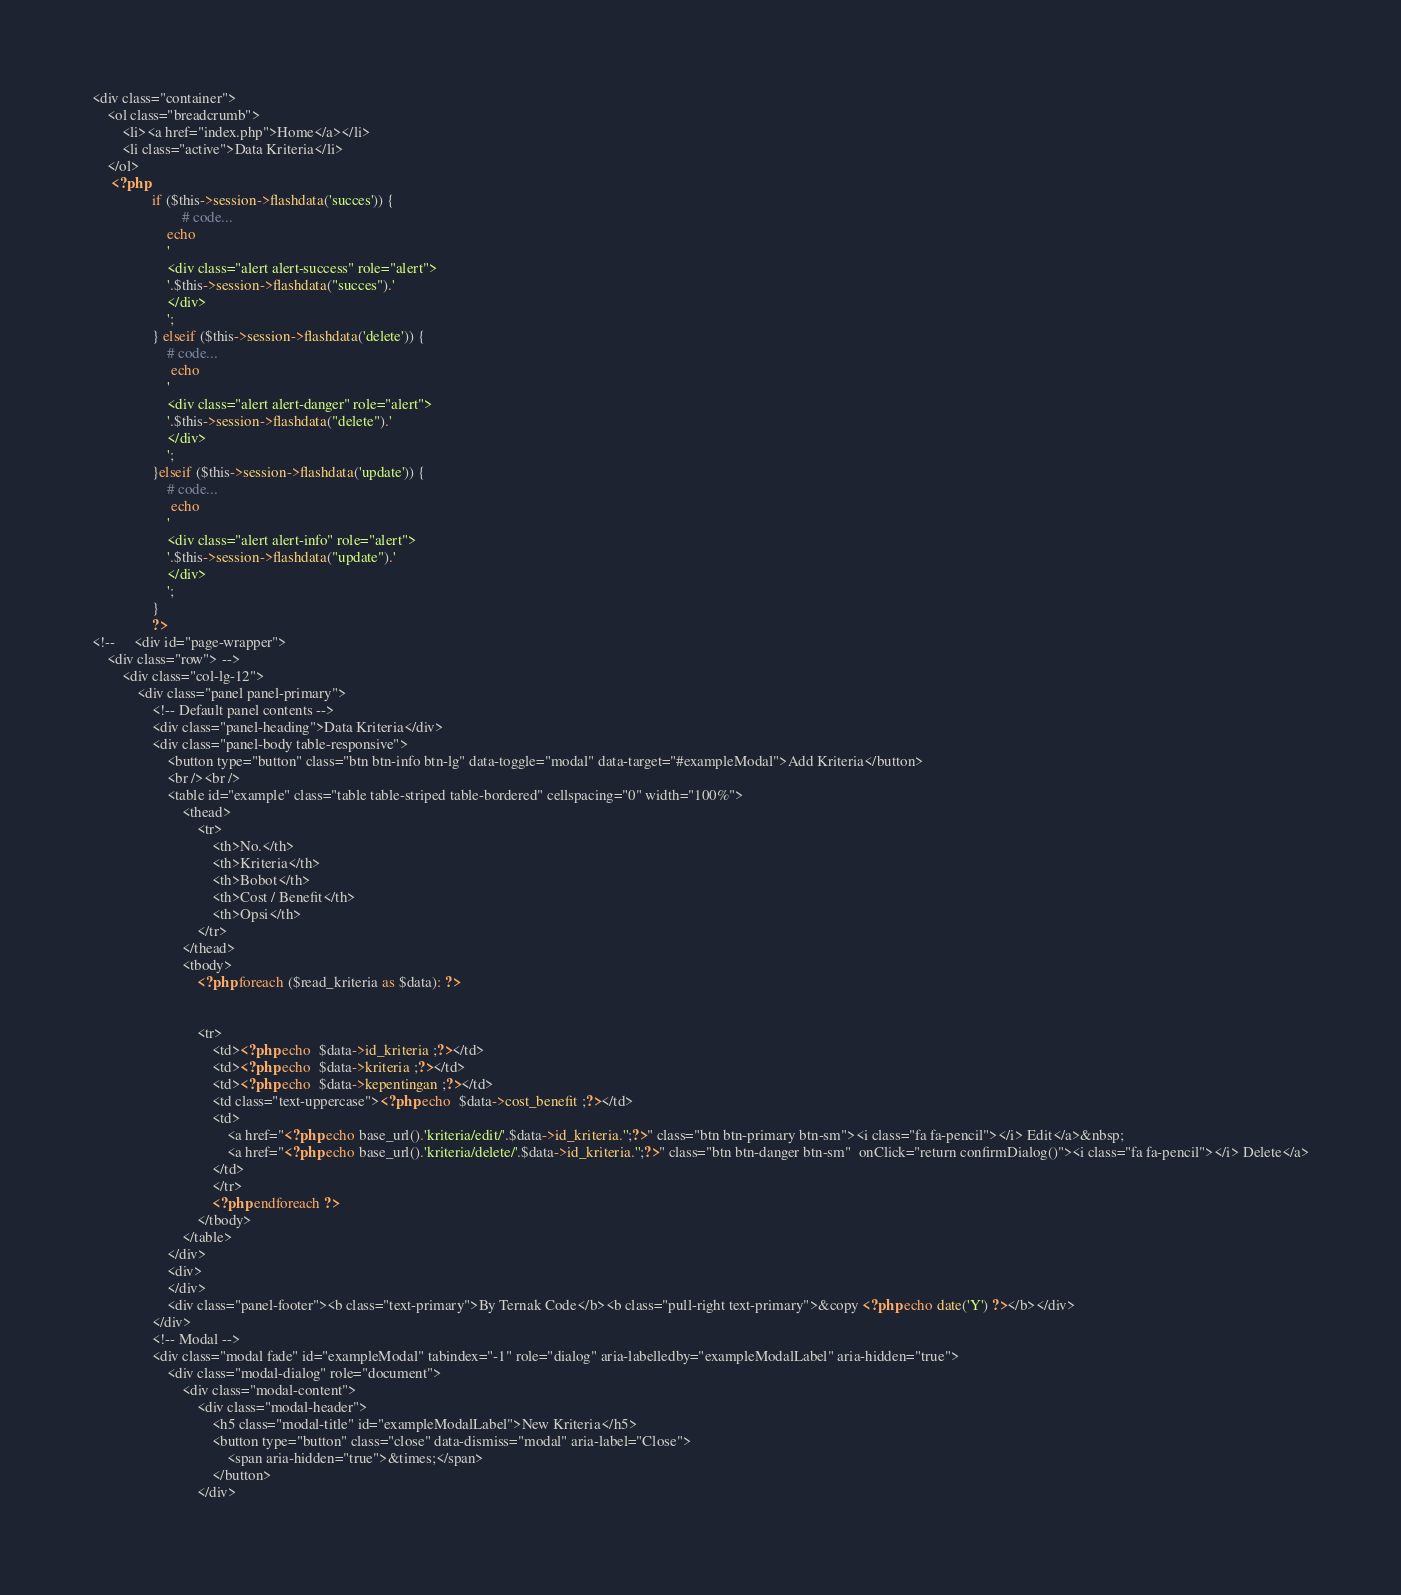Convert code to text. <code><loc_0><loc_0><loc_500><loc_500><_PHP_>
<div class="container">
	<ol class="breadcrumb">
		<li><a href="index.php">Home</a></li>
		<li class="active">Data Kriteria</li>
	</ol>
	 <?php 
                if ($this->session->flashdata('succes')) {
                        # code...
                    echo 
                    '
                    <div class="alert alert-success" role="alert">
                    '.$this->session->flashdata("succes").'
                    </div>
                    ';
                } elseif ($this->session->flashdata('delete')) {
                	# code...
                	 echo 
                    '
                    <div class="alert alert-danger" role="alert">
                    '.$this->session->flashdata("delete").'
                    </div>
                    ';
                }elseif ($this->session->flashdata('update')) {
                	# code...
                	 echo 
                    '
                    <div class="alert alert-info" role="alert">
                    '.$this->session->flashdata("update").'
                    </div>
                    ';
                }
                ?>
<!-- 	<div id="page-wrapper">
	<div class="row"> -->
		<div class="col-lg-12">
			<div class="panel panel-primary">
				<!-- Default panel contents -->
				<div class="panel-heading">Data Kriteria</div>
				<div class="panel-body table-responsive">
					<button type="button" class="btn btn-info btn-lg" data-toggle="modal" data-target="#exampleModal">Add Kriteria</button>
					<br /><br />
					<table id="example" class="table table-striped table-bordered" cellspacing="0" width="100%">
						<thead>
							<tr>
								<th>No.</th>
								<th>Kriteria</th>
								<th>Bobot</th>
								<th>Cost / Benefit</th>
								<th>Opsi</th>
							</tr>
						</thead>
						<tbody>
							<?php foreach ($read_kriteria as $data): ?>
								
							
							<tr>
								<td><?php echo  $data->id_kriteria ;?></td>
								<td><?php echo  $data->kriteria ;?></td>
								<td><?php echo  $data->kepentingan ;?></td>
								<td class="text-uppercase"><?php echo  $data->cost_benefit ;?></td>
								<td>														 
									<a href="<?php echo base_url().'kriteria/edit/'.$data->id_kriteria.'';?>" class="btn btn-primary btn-sm"><i class="fa fa-pencil"></i> Edit</a>&nbsp;
									<a href="<?php echo base_url().'kriteria/delete/'.$data->id_kriteria.'';?>" class="btn btn-danger btn-sm"  onClick="return confirmDialog()"><i class="fa fa-pencil"></i> Delete</a>
								</td>
								</tr>
								<?php endforeach ?>
							</tbody>
						</table>
					</div>
					<div>
					</div>
					<div class="panel-footer"><b class="text-primary">By Ternak Code</b><b class="pull-right text-primary">&copy <?php echo date('Y') ?></b></div>
				</div>
				<!-- Modal -->
				<div class="modal fade" id="exampleModal" tabindex="-1" role="dialog" aria-labelledby="exampleModalLabel" aria-hidden="true">
					<div class="modal-dialog" role="document">
						<div class="modal-content">
							<div class="modal-header">
								<h5 class="modal-title" id="exampleModalLabel">New Kriteria</h5>
								<button type="button" class="close" data-dismiss="modal" aria-label="Close">
									<span aria-hidden="true">&times;</span>
								</button>
							</div></code> 